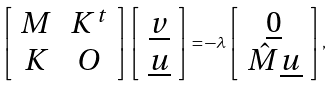Convert formula to latex. <formula><loc_0><loc_0><loc_500><loc_500>\left [ \begin{array} { c c } M & K ^ { t } \\ K & O \end{array} \right ] \left [ \begin{array} { c } \underline { v } \\ \underline { u } \end{array} \right ] = - \lambda \left [ \begin{array} { c c } \underline { 0 } \\ \hat { M } \underline { u } \end{array} \right ] ,</formula> 